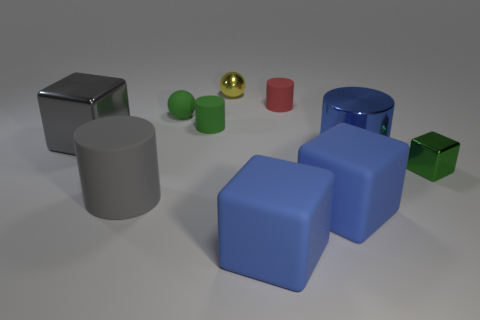What number of things are green balls that are in front of the metal ball or tiny green spheres?
Offer a terse response. 1. What number of objects are blue cylinders or large blue cylinders in front of the yellow object?
Your answer should be compact. 1. How many rubber cylinders are the same size as the gray rubber thing?
Keep it short and to the point. 0. Is the number of yellow shiny things that are in front of the green sphere less than the number of big rubber blocks that are behind the tiny red rubber cylinder?
Give a very brief answer. No. What number of matte things are large gray objects or green spheres?
Provide a succinct answer. 2. The tiny yellow object is what shape?
Provide a succinct answer. Sphere. There is another yellow sphere that is the same size as the rubber sphere; what is it made of?
Offer a very short reply. Metal. What number of small objects are red cylinders or blue metallic cylinders?
Offer a terse response. 1. Are any blue matte blocks visible?
Your answer should be compact. Yes. What is the size of the gray cube that is made of the same material as the blue cylinder?
Offer a terse response. Large. 